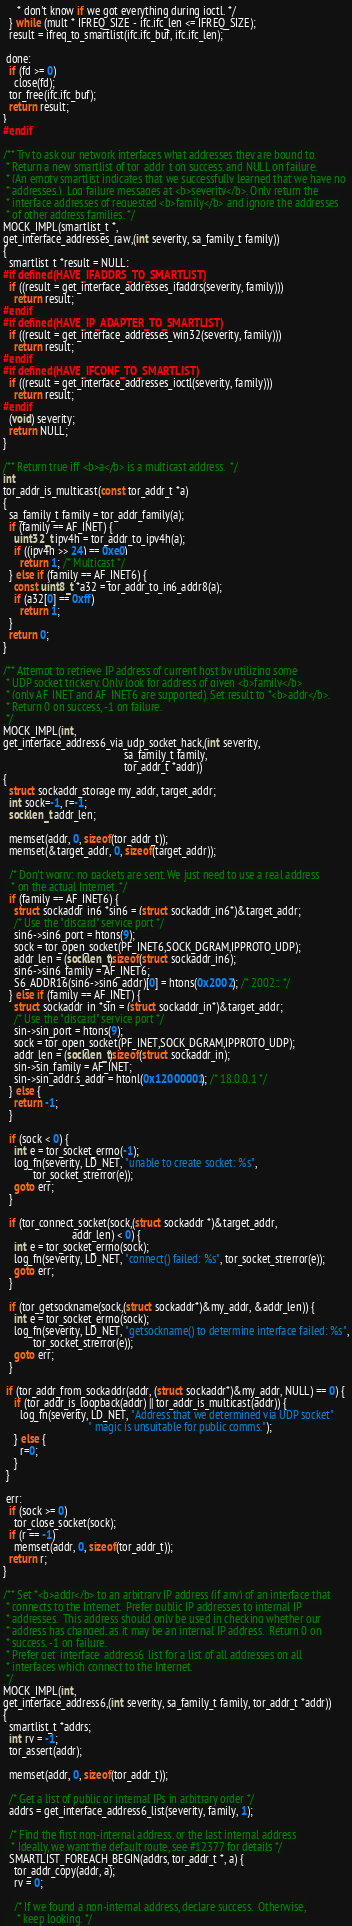Convert code to text. <code><loc_0><loc_0><loc_500><loc_500><_C_>     * don't know if we got everything during ioctl. */
  } while (mult * IFREQ_SIZE - ifc.ifc_len <= IFREQ_SIZE);
  result = ifreq_to_smartlist(ifc.ifc_buf, ifc.ifc_len);

 done:
  if (fd >= 0)
    close(fd);
  tor_free(ifc.ifc_buf);
  return result;
}
#endif

/** Try to ask our network interfaces what addresses they are bound to.
 * Return a new smartlist of tor_addr_t on success, and NULL on failure.
 * (An empty smartlist indicates that we successfully learned that we have no
 * addresses.)  Log failure messages at <b>severity</b>. Only return the
 * interface addresses of requested <b>family</b> and ignore the addresses
 * of other address families. */
MOCK_IMPL(smartlist_t *,
get_interface_addresses_raw,(int severity, sa_family_t family))
{
  smartlist_t *result = NULL;
#if defined(HAVE_IFADDRS_TO_SMARTLIST)
  if ((result = get_interface_addresses_ifaddrs(severity, family)))
    return result;
#endif
#if defined(HAVE_IP_ADAPTER_TO_SMARTLIST)
  if ((result = get_interface_addresses_win32(severity, family)))
    return result;
#endif
#if defined(HAVE_IFCONF_TO_SMARTLIST)
  if ((result = get_interface_addresses_ioctl(severity, family)))
    return result;
#endif
  (void) severity;
  return NULL;
}

/** Return true iff <b>a</b> is a multicast address.  */
int
tor_addr_is_multicast(const tor_addr_t *a)
{
  sa_family_t family = tor_addr_family(a);
  if (family == AF_INET) {
    uint32_t ipv4h = tor_addr_to_ipv4h(a);
    if ((ipv4h >> 24) == 0xe0)
      return 1; /* Multicast */
  } else if (family == AF_INET6) {
    const uint8_t *a32 = tor_addr_to_in6_addr8(a);
    if (a32[0] == 0xff)
      return 1;
  }
  return 0;
}

/** Attempt to retrieve IP address of current host by utilizing some
 * UDP socket trickery. Only look for address of given <b>family</b>
 * (only AF_INET and AF_INET6 are supported). Set result to *<b>addr</b>.
 * Return 0 on success, -1 on failure.
 */
MOCK_IMPL(int,
get_interface_address6_via_udp_socket_hack,(int severity,
                                            sa_family_t family,
                                            tor_addr_t *addr))
{
  struct sockaddr_storage my_addr, target_addr;
  int sock=-1, r=-1;
  socklen_t addr_len;

  memset(addr, 0, sizeof(tor_addr_t));
  memset(&target_addr, 0, sizeof(target_addr));

  /* Don't worry: no packets are sent. We just need to use a real address
   * on the actual Internet. */
  if (family == AF_INET6) {
    struct sockaddr_in6 *sin6 = (struct sockaddr_in6*)&target_addr;
    /* Use the "discard" service port */
    sin6->sin6_port = htons(9);
    sock = tor_open_socket(PF_INET6,SOCK_DGRAM,IPPROTO_UDP);
    addr_len = (socklen_t)sizeof(struct sockaddr_in6);
    sin6->sin6_family = AF_INET6;
    S6_ADDR16(sin6->sin6_addr)[0] = htons(0x2002); /* 2002:: */
  } else if (family == AF_INET) {
    struct sockaddr_in *sin = (struct sockaddr_in*)&target_addr;
    /* Use the "discard" service port */
    sin->sin_port = htons(9);
    sock = tor_open_socket(PF_INET,SOCK_DGRAM,IPPROTO_UDP);
    addr_len = (socklen_t)sizeof(struct sockaddr_in);
    sin->sin_family = AF_INET;
    sin->sin_addr.s_addr = htonl(0x12000001); /* 18.0.0.1 */
  } else {
    return -1;
  }

  if (sock < 0) {
    int e = tor_socket_errno(-1);
    log_fn(severity, LD_NET, "unable to create socket: %s",
           tor_socket_strerror(e));
    goto err;
  }

  if (tor_connect_socket(sock,(struct sockaddr *)&target_addr,
                         addr_len) < 0) {
    int e = tor_socket_errno(sock);
    log_fn(severity, LD_NET, "connect() failed: %s", tor_socket_strerror(e));
    goto err;
  }

  if (tor_getsockname(sock,(struct sockaddr*)&my_addr, &addr_len)) {
    int e = tor_socket_errno(sock);
    log_fn(severity, LD_NET, "getsockname() to determine interface failed: %s",
           tor_socket_strerror(e));
    goto err;
  }

 if (tor_addr_from_sockaddr(addr, (struct sockaddr*)&my_addr, NULL) == 0) {
    if (tor_addr_is_loopback(addr) || tor_addr_is_multicast(addr)) {
      log_fn(severity, LD_NET, "Address that we determined via UDP socket"
                               " magic is unsuitable for public comms.");
    } else {
      r=0;
    }
 }

 err:
  if (sock >= 0)
    tor_close_socket(sock);
  if (r == -1)
    memset(addr, 0, sizeof(tor_addr_t));
  return r;
}

/** Set *<b>addr</b> to an arbitrary IP address (if any) of an interface that
 * connects to the Internet.  Prefer public IP addresses to internal IP
 * addresses.  This address should only be used in checking whether our
 * address has changed, as it may be an internal IP address.  Return 0 on
 * success, -1 on failure.
 * Prefer get_interface_address6_list for a list of all addresses on all
 * interfaces which connect to the Internet.
 */
MOCK_IMPL(int,
get_interface_address6,(int severity, sa_family_t family, tor_addr_t *addr))
{
  smartlist_t *addrs;
  int rv = -1;
  tor_assert(addr);

  memset(addr, 0, sizeof(tor_addr_t));

  /* Get a list of public or internal IPs in arbitrary order */
  addrs = get_interface_address6_list(severity, family, 1);

  /* Find the first non-internal address, or the last internal address
   * Ideally, we want the default route, see #12377 for details */
  SMARTLIST_FOREACH_BEGIN(addrs, tor_addr_t *, a) {
    tor_addr_copy(addr, a);
    rv = 0;

    /* If we found a non-internal address, declare success.  Otherwise,
     * keep looking. */</code> 